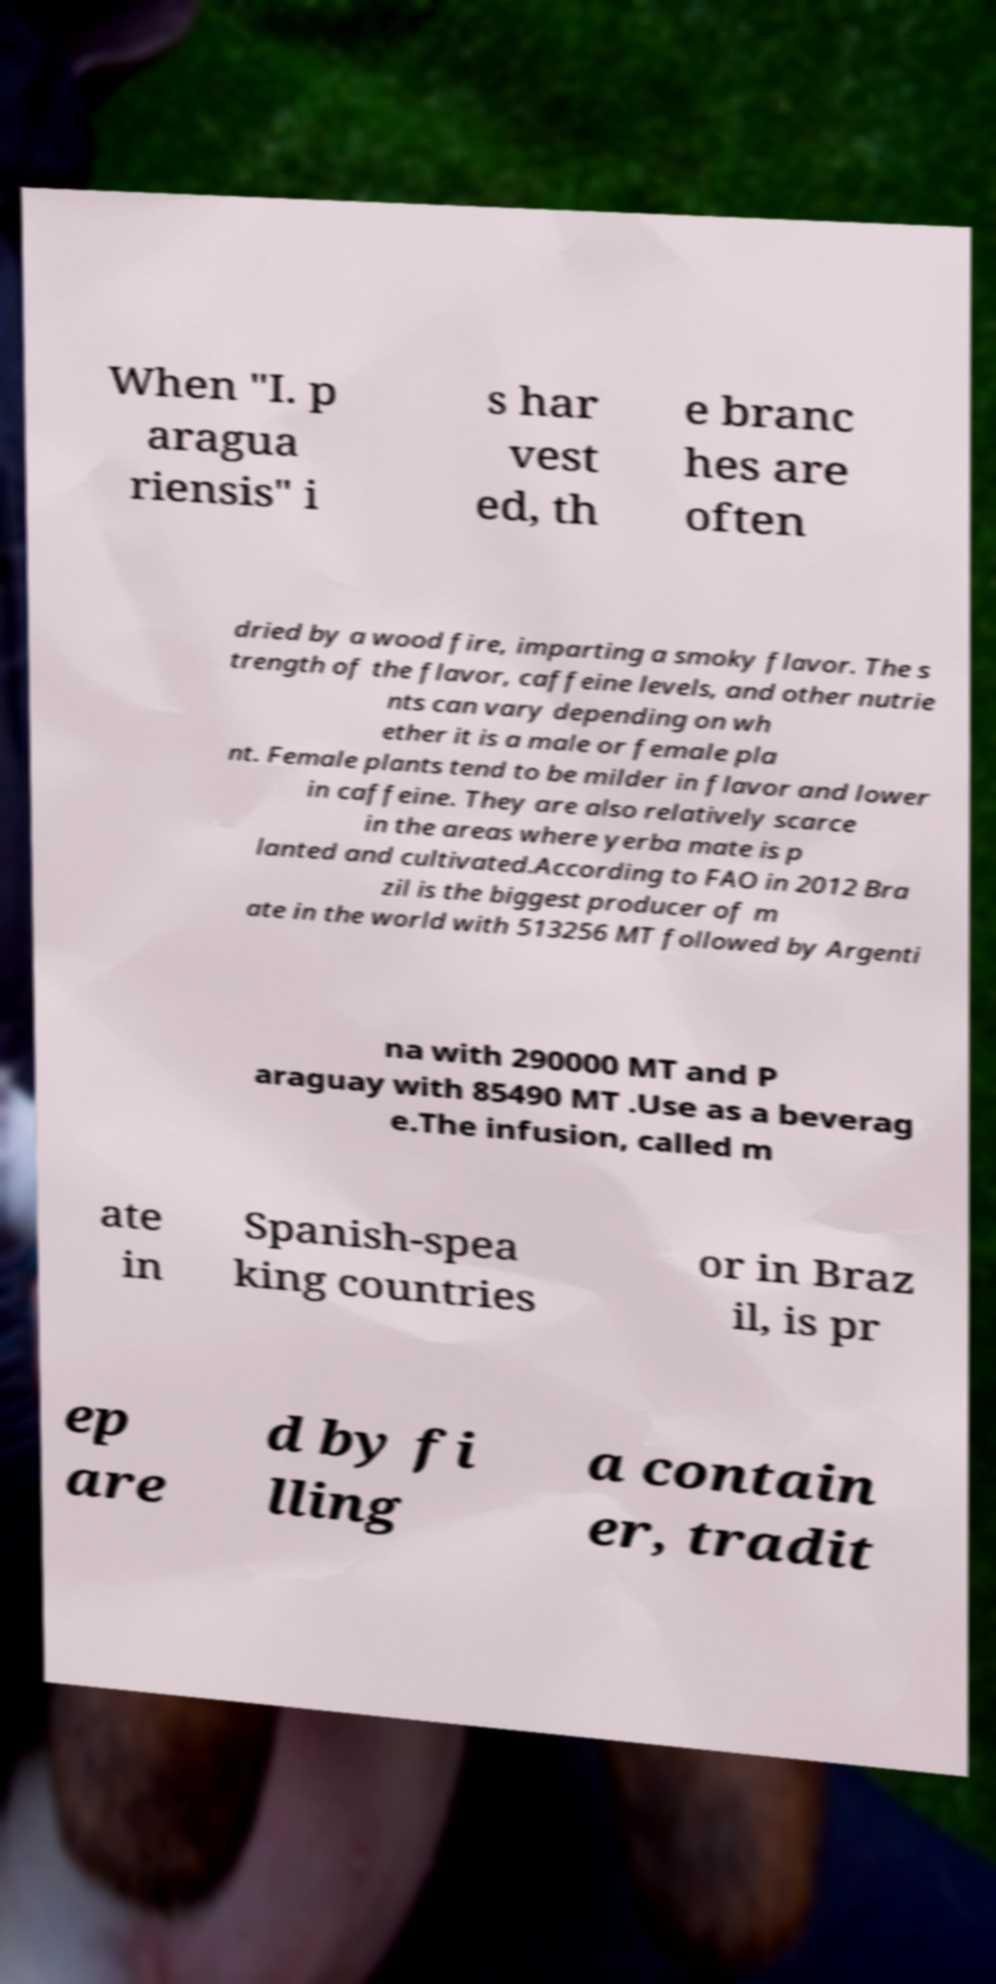What messages or text are displayed in this image? I need them in a readable, typed format. When "I. p aragua riensis" i s har vest ed, th e branc hes are often dried by a wood fire, imparting a smoky flavor. The s trength of the flavor, caffeine levels, and other nutrie nts can vary depending on wh ether it is a male or female pla nt. Female plants tend to be milder in flavor and lower in caffeine. They are also relatively scarce in the areas where yerba mate is p lanted and cultivated.According to FAO in 2012 Bra zil is the biggest producer of m ate in the world with 513256 MT followed by Argenti na with 290000 MT and P araguay with 85490 MT .Use as a beverag e.The infusion, called m ate in Spanish-spea king countries or in Braz il, is pr ep are d by fi lling a contain er, tradit 